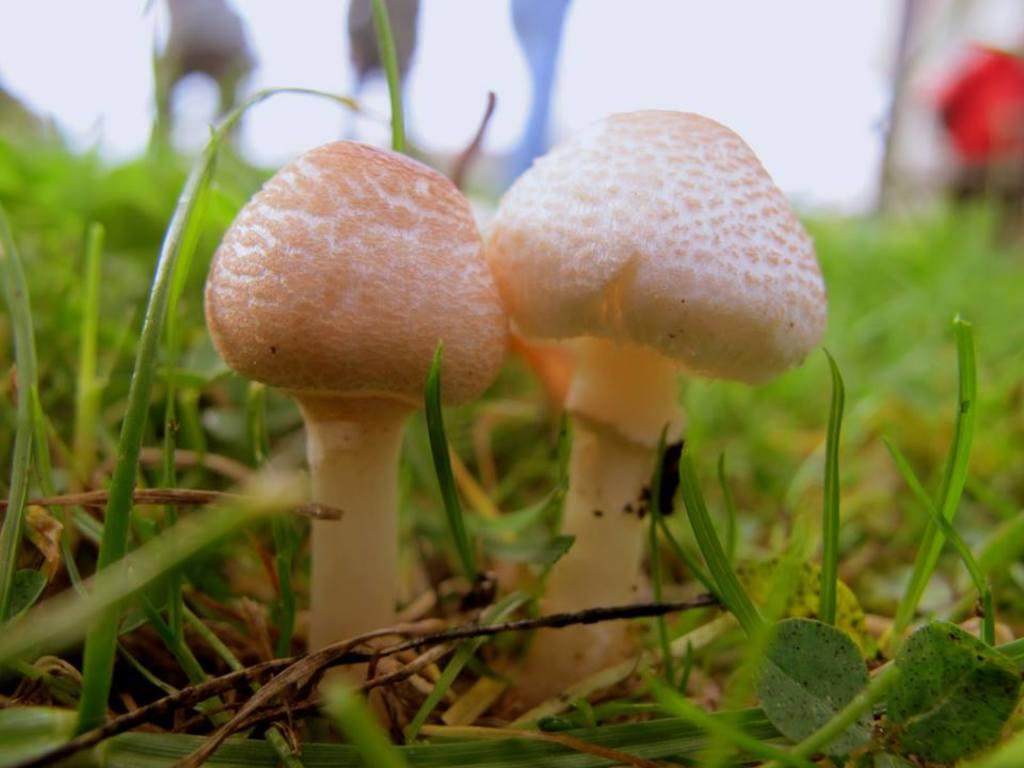How many mushrooms are present in the image? There are two mushrooms in the image. What color are the mushrooms? The mushrooms are cream in color. What type of vegetation is visible in the image? The image contains grass. Can you describe the background of the image? The background of the image is blurred. What type of pencil can be seen in the image? There is no pencil present in the image. 